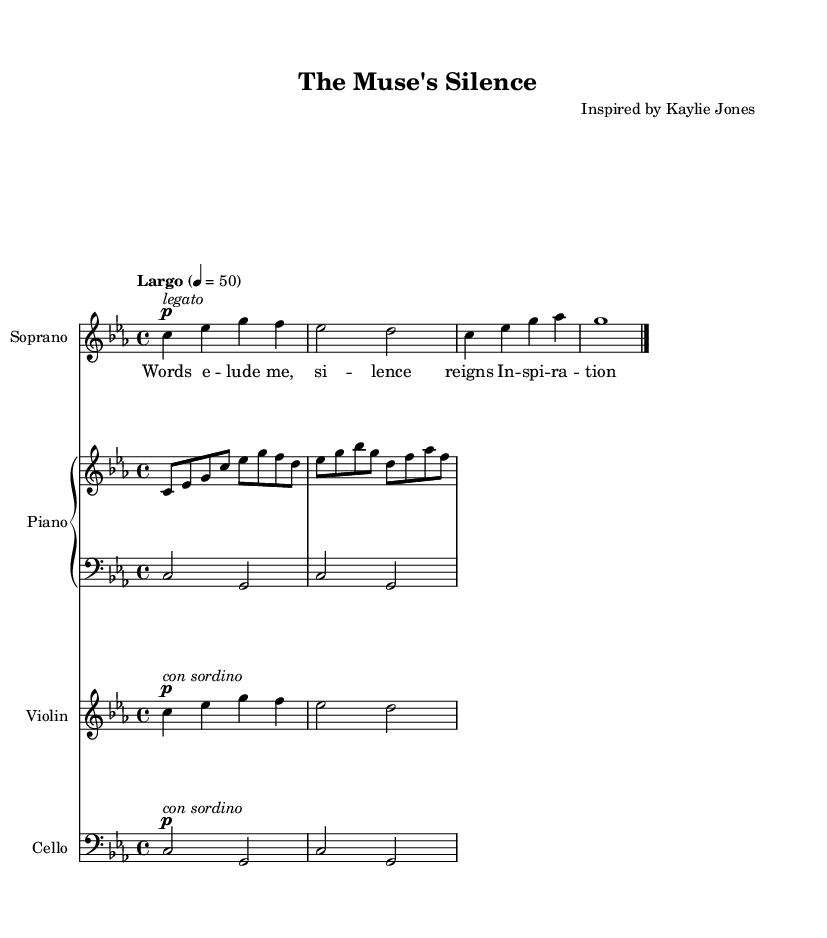What is the key signature of this music? The key signature is indicated at the beginning of the score, following the '\key' command. Here, it shows C minor, which contains three flats: B-flat, E-flat, and A-flat.
Answer: C minor What is the time signature of this music? The time signature appears after the key signature and is represented by the '\time' command. In this case, it shows 4/4, meaning there are four beats in each measure, and the quarter note gets one beat.
Answer: 4/4 What is the tempo marking of this piece? The tempo marking is found at the beginning of the score, indicated by the '\tempo' command. It indicates "Largo," which suggests a slow tempo typically around 40-60 beats per minute.
Answer: Largo How many measures are in the soprano part? To find the number of measures, we count the separate segments distinguished by the bar lines. In the soprano part, there are three measures before the final bar line.
Answer: 3 Which instruments are included in this score? The instruments are indicated by the 'instrumentName' properties in the score. It lists Soprano, Piano (with upper and lower staves), Violin, and Cello.
Answer: Soprano, Piano, Violin, Cello How many notes are in the first measure of the piano right hand? The first measure of the piano right hand contains four notes, as shown by the quarter note entries in that measure.
Answer: 4 What is the theme explored in the lyrics? The lyrics present a theme of inspiration and the challenges of silence, suggesting a struggle with writer's block or invoking creative thought, as highlighted by phrases like "silence reigns" and "inspiration wanes."
Answer: Inspiration and writer's block 